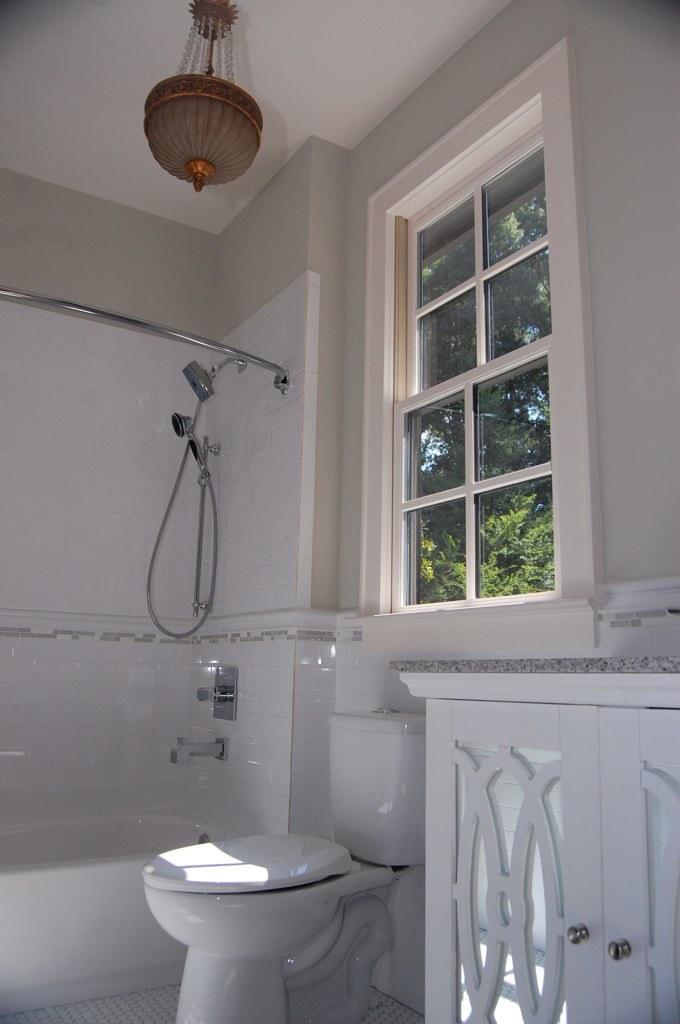Please provide a concise description of this image. In this image I can see a toilet sink. On the right there is a cupboard. In the background I can see a window. 